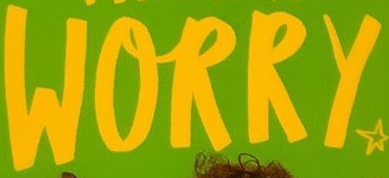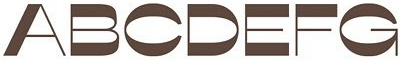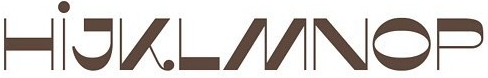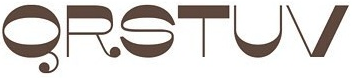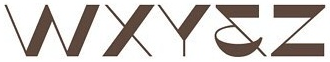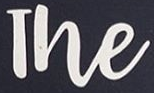What text is displayed in these images sequentially, separated by a semicolon? WORRY; ABCDEFG; HİJKLMNOP; QRSTUV; WXY&Z; The 